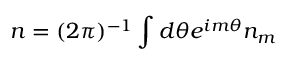<formula> <loc_0><loc_0><loc_500><loc_500>n = ( 2 \pi ) ^ { - 1 } \int d \theta e ^ { i m \theta } n _ { m }</formula> 